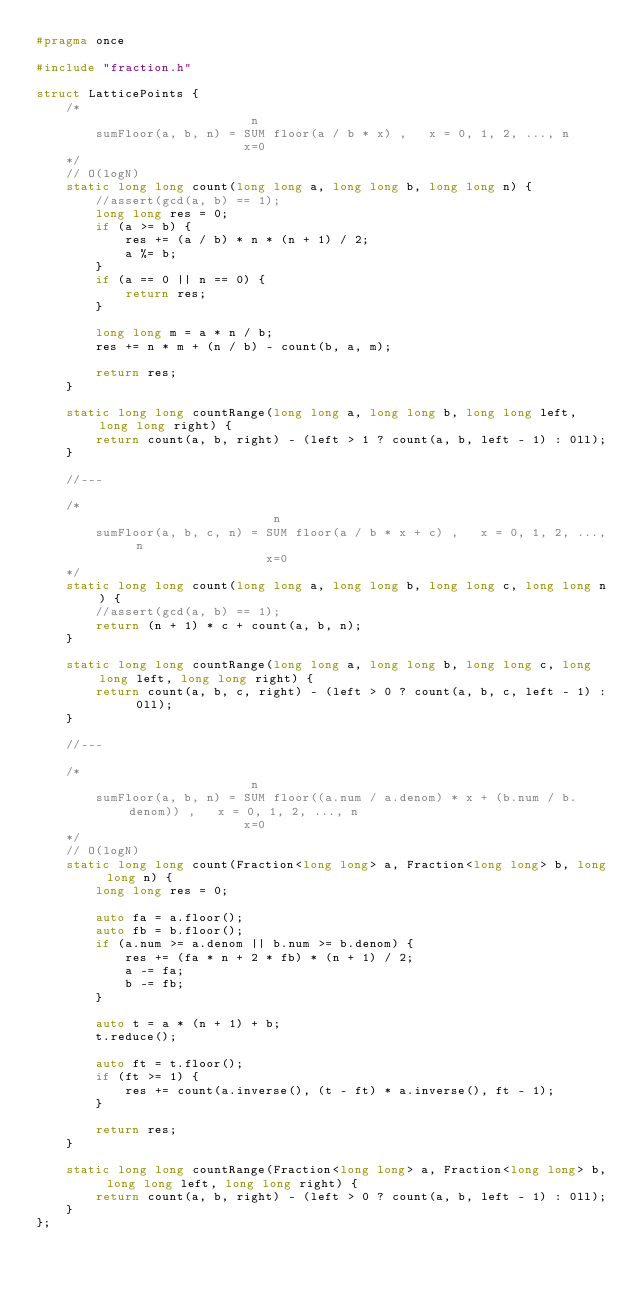<code> <loc_0><loc_0><loc_500><loc_500><_C_>#pragma once

#include "fraction.h"

struct LatticePoints {
    /*
                             n
        sumFloor(a, b, n) = SUM floor(a / b * x) ,   x = 0, 1, 2, ..., n
                            x=0
    */
    // O(logN)
    static long long count(long long a, long long b, long long n) {
        //assert(gcd(a, b) == 1);
        long long res = 0;
        if (a >= b) {
            res += (a / b) * n * (n + 1) / 2;
            a %= b;
        }
        if (a == 0 || n == 0) {
            return res;
        }

        long long m = a * n / b;
        res += n * m + (n / b) - count(b, a, m);

        return res;
    }

    static long long countRange(long long a, long long b, long long left, long long right) {
        return count(a, b, right) - (left > 1 ? count(a, b, left - 1) : 0ll);
    }

    //---

    /*
                                n
        sumFloor(a, b, c, n) = SUM floor(a / b * x + c) ,   x = 0, 1, 2, ..., n
                               x=0
    */
    static long long count(long long a, long long b, long long c, long long n) {
        //assert(gcd(a, b) == 1);
        return (n + 1) * c + count(a, b, n);
    }

    static long long countRange(long long a, long long b, long long c, long long left, long long right) {
        return count(a, b, c, right) - (left > 0 ? count(a, b, c, left - 1) : 0ll);
    }

    //---

    /*
                             n
        sumFloor(a, b, n) = SUM floor((a.num / a.denom) * x + (b.num / b.denom)) ,   x = 0, 1, 2, ..., n
                            x=0
    */
    // O(logN)
    static long long count(Fraction<long long> a, Fraction<long long> b, long long n) {
        long long res = 0;

        auto fa = a.floor();
        auto fb = b.floor();
        if (a.num >= a.denom || b.num >= b.denom) {
            res += (fa * n + 2 * fb) * (n + 1) / 2;
            a -= fa;
            b -= fb;
        }

        auto t = a * (n + 1) + b;
        t.reduce();

        auto ft = t.floor();
        if (ft >= 1) {
            res += count(a.inverse(), (t - ft) * a.inverse(), ft - 1);
        }

        return res;
    }

    static long long countRange(Fraction<long long> a, Fraction<long long> b, long long left, long long right) {
        return count(a, b, right) - (left > 0 ? count(a, b, left - 1) : 0ll);
    }
};
</code> 